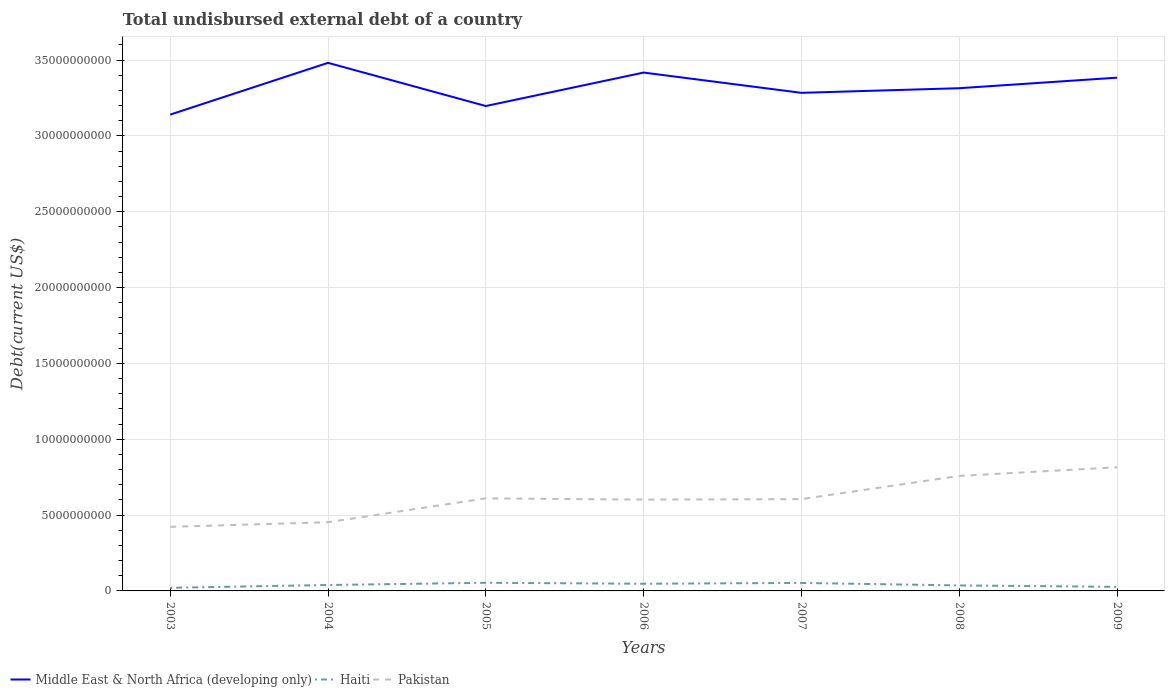Does the line corresponding to Middle East & North Africa (developing only) intersect with the line corresponding to Haiti?
Give a very brief answer. No. Across all years, what is the maximum total undisbursed external debt in Pakistan?
Offer a terse response. 4.22e+09. What is the total total undisbursed external debt in Haiti in the graph?
Provide a short and direct response. -2.67e+08. What is the difference between the highest and the second highest total undisbursed external debt in Pakistan?
Your answer should be compact. 3.93e+09. What is the difference between the highest and the lowest total undisbursed external debt in Middle East & North Africa (developing only)?
Your response must be concise. 3. Is the total undisbursed external debt in Middle East & North Africa (developing only) strictly greater than the total undisbursed external debt in Haiti over the years?
Keep it short and to the point. No. How many lines are there?
Offer a very short reply. 3. How many years are there in the graph?
Offer a terse response. 7. Does the graph contain any zero values?
Give a very brief answer. No. Does the graph contain grids?
Provide a short and direct response. Yes. How are the legend labels stacked?
Your response must be concise. Horizontal. What is the title of the graph?
Your response must be concise. Total undisbursed external debt of a country. Does "Switzerland" appear as one of the legend labels in the graph?
Give a very brief answer. No. What is the label or title of the X-axis?
Make the answer very short. Years. What is the label or title of the Y-axis?
Your answer should be very brief. Debt(current US$). What is the Debt(current US$) in Middle East & North Africa (developing only) in 2003?
Your answer should be very brief. 3.14e+1. What is the Debt(current US$) of Haiti in 2003?
Provide a short and direct response. 2.06e+08. What is the Debt(current US$) of Pakistan in 2003?
Your response must be concise. 4.22e+09. What is the Debt(current US$) of Middle East & North Africa (developing only) in 2004?
Keep it short and to the point. 3.48e+1. What is the Debt(current US$) in Haiti in 2004?
Ensure brevity in your answer.  3.90e+08. What is the Debt(current US$) of Pakistan in 2004?
Offer a terse response. 4.53e+09. What is the Debt(current US$) in Middle East & North Africa (developing only) in 2005?
Offer a terse response. 3.20e+1. What is the Debt(current US$) of Haiti in 2005?
Offer a very short reply. 5.37e+08. What is the Debt(current US$) of Pakistan in 2005?
Your answer should be very brief. 6.10e+09. What is the Debt(current US$) of Middle East & North Africa (developing only) in 2006?
Make the answer very short. 3.42e+1. What is the Debt(current US$) of Haiti in 2006?
Keep it short and to the point. 4.73e+08. What is the Debt(current US$) in Pakistan in 2006?
Your response must be concise. 6.02e+09. What is the Debt(current US$) of Middle East & North Africa (developing only) in 2007?
Provide a succinct answer. 3.28e+1. What is the Debt(current US$) in Haiti in 2007?
Give a very brief answer. 5.27e+08. What is the Debt(current US$) of Pakistan in 2007?
Your response must be concise. 6.05e+09. What is the Debt(current US$) of Middle East & North Africa (developing only) in 2008?
Keep it short and to the point. 3.31e+1. What is the Debt(current US$) of Haiti in 2008?
Offer a terse response. 3.63e+08. What is the Debt(current US$) of Pakistan in 2008?
Offer a terse response. 7.58e+09. What is the Debt(current US$) of Middle East & North Africa (developing only) in 2009?
Your answer should be very brief. 3.38e+1. What is the Debt(current US$) in Haiti in 2009?
Your answer should be very brief. 2.68e+08. What is the Debt(current US$) of Pakistan in 2009?
Ensure brevity in your answer.  8.15e+09. Across all years, what is the maximum Debt(current US$) in Middle East & North Africa (developing only)?
Offer a terse response. 3.48e+1. Across all years, what is the maximum Debt(current US$) in Haiti?
Your answer should be compact. 5.37e+08. Across all years, what is the maximum Debt(current US$) of Pakistan?
Offer a very short reply. 8.15e+09. Across all years, what is the minimum Debt(current US$) of Middle East & North Africa (developing only)?
Give a very brief answer. 3.14e+1. Across all years, what is the minimum Debt(current US$) in Haiti?
Offer a terse response. 2.06e+08. Across all years, what is the minimum Debt(current US$) in Pakistan?
Ensure brevity in your answer.  4.22e+09. What is the total Debt(current US$) in Middle East & North Africa (developing only) in the graph?
Make the answer very short. 2.32e+11. What is the total Debt(current US$) in Haiti in the graph?
Ensure brevity in your answer.  2.76e+09. What is the total Debt(current US$) of Pakistan in the graph?
Keep it short and to the point. 4.27e+1. What is the difference between the Debt(current US$) in Middle East & North Africa (developing only) in 2003 and that in 2004?
Make the answer very short. -3.41e+09. What is the difference between the Debt(current US$) in Haiti in 2003 and that in 2004?
Make the answer very short. -1.83e+08. What is the difference between the Debt(current US$) of Pakistan in 2003 and that in 2004?
Provide a succinct answer. -3.04e+08. What is the difference between the Debt(current US$) of Middle East & North Africa (developing only) in 2003 and that in 2005?
Make the answer very short. -5.65e+08. What is the difference between the Debt(current US$) in Haiti in 2003 and that in 2005?
Your answer should be compact. -3.31e+08. What is the difference between the Debt(current US$) of Pakistan in 2003 and that in 2005?
Provide a short and direct response. -1.88e+09. What is the difference between the Debt(current US$) in Middle East & North Africa (developing only) in 2003 and that in 2006?
Offer a very short reply. -2.77e+09. What is the difference between the Debt(current US$) of Haiti in 2003 and that in 2006?
Provide a short and direct response. -2.67e+08. What is the difference between the Debt(current US$) in Pakistan in 2003 and that in 2006?
Your answer should be very brief. -1.80e+09. What is the difference between the Debt(current US$) in Middle East & North Africa (developing only) in 2003 and that in 2007?
Ensure brevity in your answer.  -1.44e+09. What is the difference between the Debt(current US$) of Haiti in 2003 and that in 2007?
Make the answer very short. -3.20e+08. What is the difference between the Debt(current US$) of Pakistan in 2003 and that in 2007?
Keep it short and to the point. -1.83e+09. What is the difference between the Debt(current US$) of Middle East & North Africa (developing only) in 2003 and that in 2008?
Offer a very short reply. -1.74e+09. What is the difference between the Debt(current US$) of Haiti in 2003 and that in 2008?
Offer a very short reply. -1.56e+08. What is the difference between the Debt(current US$) in Pakistan in 2003 and that in 2008?
Make the answer very short. -3.36e+09. What is the difference between the Debt(current US$) in Middle East & North Africa (developing only) in 2003 and that in 2009?
Your response must be concise. -2.44e+09. What is the difference between the Debt(current US$) of Haiti in 2003 and that in 2009?
Your response must be concise. -6.14e+07. What is the difference between the Debt(current US$) of Pakistan in 2003 and that in 2009?
Ensure brevity in your answer.  -3.93e+09. What is the difference between the Debt(current US$) of Middle East & North Africa (developing only) in 2004 and that in 2005?
Ensure brevity in your answer.  2.85e+09. What is the difference between the Debt(current US$) of Haiti in 2004 and that in 2005?
Your answer should be compact. -1.47e+08. What is the difference between the Debt(current US$) of Pakistan in 2004 and that in 2005?
Give a very brief answer. -1.58e+09. What is the difference between the Debt(current US$) of Middle East & North Africa (developing only) in 2004 and that in 2006?
Ensure brevity in your answer.  6.42e+08. What is the difference between the Debt(current US$) of Haiti in 2004 and that in 2006?
Offer a very short reply. -8.38e+07. What is the difference between the Debt(current US$) of Pakistan in 2004 and that in 2006?
Make the answer very short. -1.49e+09. What is the difference between the Debt(current US$) in Middle East & North Africa (developing only) in 2004 and that in 2007?
Make the answer very short. 1.98e+09. What is the difference between the Debt(current US$) of Haiti in 2004 and that in 2007?
Offer a terse response. -1.37e+08. What is the difference between the Debt(current US$) in Pakistan in 2004 and that in 2007?
Keep it short and to the point. -1.52e+09. What is the difference between the Debt(current US$) of Middle East & North Africa (developing only) in 2004 and that in 2008?
Offer a terse response. 1.67e+09. What is the difference between the Debt(current US$) in Haiti in 2004 and that in 2008?
Your answer should be very brief. 2.68e+07. What is the difference between the Debt(current US$) in Pakistan in 2004 and that in 2008?
Provide a succinct answer. -3.06e+09. What is the difference between the Debt(current US$) in Middle East & North Africa (developing only) in 2004 and that in 2009?
Offer a very short reply. 9.78e+08. What is the difference between the Debt(current US$) in Haiti in 2004 and that in 2009?
Keep it short and to the point. 1.22e+08. What is the difference between the Debt(current US$) of Pakistan in 2004 and that in 2009?
Offer a very short reply. -3.63e+09. What is the difference between the Debt(current US$) in Middle East & North Africa (developing only) in 2005 and that in 2006?
Offer a very short reply. -2.21e+09. What is the difference between the Debt(current US$) of Haiti in 2005 and that in 2006?
Provide a succinct answer. 6.37e+07. What is the difference between the Debt(current US$) of Pakistan in 2005 and that in 2006?
Offer a very short reply. 8.43e+07. What is the difference between the Debt(current US$) of Middle East & North Africa (developing only) in 2005 and that in 2007?
Provide a succinct answer. -8.70e+08. What is the difference between the Debt(current US$) in Haiti in 2005 and that in 2007?
Offer a terse response. 1.06e+07. What is the difference between the Debt(current US$) of Pakistan in 2005 and that in 2007?
Provide a short and direct response. 5.10e+07. What is the difference between the Debt(current US$) of Middle East & North Africa (developing only) in 2005 and that in 2008?
Ensure brevity in your answer.  -1.18e+09. What is the difference between the Debt(current US$) in Haiti in 2005 and that in 2008?
Ensure brevity in your answer.  1.74e+08. What is the difference between the Debt(current US$) in Pakistan in 2005 and that in 2008?
Provide a succinct answer. -1.48e+09. What is the difference between the Debt(current US$) in Middle East & North Africa (developing only) in 2005 and that in 2009?
Offer a terse response. -1.87e+09. What is the difference between the Debt(current US$) in Haiti in 2005 and that in 2009?
Provide a short and direct response. 2.69e+08. What is the difference between the Debt(current US$) of Pakistan in 2005 and that in 2009?
Make the answer very short. -2.05e+09. What is the difference between the Debt(current US$) in Middle East & North Africa (developing only) in 2006 and that in 2007?
Give a very brief answer. 1.34e+09. What is the difference between the Debt(current US$) in Haiti in 2006 and that in 2007?
Your answer should be compact. -5.31e+07. What is the difference between the Debt(current US$) in Pakistan in 2006 and that in 2007?
Provide a short and direct response. -3.33e+07. What is the difference between the Debt(current US$) of Middle East & North Africa (developing only) in 2006 and that in 2008?
Provide a succinct answer. 1.03e+09. What is the difference between the Debt(current US$) in Haiti in 2006 and that in 2008?
Your answer should be very brief. 1.11e+08. What is the difference between the Debt(current US$) in Pakistan in 2006 and that in 2008?
Your answer should be compact. -1.56e+09. What is the difference between the Debt(current US$) in Middle East & North Africa (developing only) in 2006 and that in 2009?
Make the answer very short. 3.36e+08. What is the difference between the Debt(current US$) in Haiti in 2006 and that in 2009?
Make the answer very short. 2.06e+08. What is the difference between the Debt(current US$) of Pakistan in 2006 and that in 2009?
Ensure brevity in your answer.  -2.13e+09. What is the difference between the Debt(current US$) in Middle East & North Africa (developing only) in 2007 and that in 2008?
Your answer should be very brief. -3.05e+08. What is the difference between the Debt(current US$) in Haiti in 2007 and that in 2008?
Your answer should be compact. 1.64e+08. What is the difference between the Debt(current US$) of Pakistan in 2007 and that in 2008?
Your answer should be compact. -1.53e+09. What is the difference between the Debt(current US$) of Middle East & North Africa (developing only) in 2007 and that in 2009?
Provide a short and direct response. -1.00e+09. What is the difference between the Debt(current US$) in Haiti in 2007 and that in 2009?
Your answer should be compact. 2.59e+08. What is the difference between the Debt(current US$) in Pakistan in 2007 and that in 2009?
Your response must be concise. -2.10e+09. What is the difference between the Debt(current US$) of Middle East & North Africa (developing only) in 2008 and that in 2009?
Provide a succinct answer. -6.95e+08. What is the difference between the Debt(current US$) of Haiti in 2008 and that in 2009?
Provide a short and direct response. 9.49e+07. What is the difference between the Debt(current US$) in Pakistan in 2008 and that in 2009?
Offer a very short reply. -5.69e+08. What is the difference between the Debt(current US$) of Middle East & North Africa (developing only) in 2003 and the Debt(current US$) of Haiti in 2004?
Provide a short and direct response. 3.10e+1. What is the difference between the Debt(current US$) of Middle East & North Africa (developing only) in 2003 and the Debt(current US$) of Pakistan in 2004?
Keep it short and to the point. 2.69e+1. What is the difference between the Debt(current US$) of Haiti in 2003 and the Debt(current US$) of Pakistan in 2004?
Provide a succinct answer. -4.32e+09. What is the difference between the Debt(current US$) of Middle East & North Africa (developing only) in 2003 and the Debt(current US$) of Haiti in 2005?
Ensure brevity in your answer.  3.09e+1. What is the difference between the Debt(current US$) of Middle East & North Africa (developing only) in 2003 and the Debt(current US$) of Pakistan in 2005?
Your answer should be very brief. 2.53e+1. What is the difference between the Debt(current US$) of Haiti in 2003 and the Debt(current US$) of Pakistan in 2005?
Your response must be concise. -5.90e+09. What is the difference between the Debt(current US$) of Middle East & North Africa (developing only) in 2003 and the Debt(current US$) of Haiti in 2006?
Your response must be concise. 3.09e+1. What is the difference between the Debt(current US$) of Middle East & North Africa (developing only) in 2003 and the Debt(current US$) of Pakistan in 2006?
Your answer should be very brief. 2.54e+1. What is the difference between the Debt(current US$) in Haiti in 2003 and the Debt(current US$) in Pakistan in 2006?
Make the answer very short. -5.81e+09. What is the difference between the Debt(current US$) in Middle East & North Africa (developing only) in 2003 and the Debt(current US$) in Haiti in 2007?
Your answer should be compact. 3.09e+1. What is the difference between the Debt(current US$) of Middle East & North Africa (developing only) in 2003 and the Debt(current US$) of Pakistan in 2007?
Offer a terse response. 2.54e+1. What is the difference between the Debt(current US$) in Haiti in 2003 and the Debt(current US$) in Pakistan in 2007?
Your answer should be compact. -5.85e+09. What is the difference between the Debt(current US$) in Middle East & North Africa (developing only) in 2003 and the Debt(current US$) in Haiti in 2008?
Keep it short and to the point. 3.10e+1. What is the difference between the Debt(current US$) of Middle East & North Africa (developing only) in 2003 and the Debt(current US$) of Pakistan in 2008?
Offer a very short reply. 2.38e+1. What is the difference between the Debt(current US$) in Haiti in 2003 and the Debt(current US$) in Pakistan in 2008?
Your response must be concise. -7.38e+09. What is the difference between the Debt(current US$) in Middle East & North Africa (developing only) in 2003 and the Debt(current US$) in Haiti in 2009?
Offer a terse response. 3.11e+1. What is the difference between the Debt(current US$) of Middle East & North Africa (developing only) in 2003 and the Debt(current US$) of Pakistan in 2009?
Keep it short and to the point. 2.33e+1. What is the difference between the Debt(current US$) of Haiti in 2003 and the Debt(current US$) of Pakistan in 2009?
Provide a succinct answer. -7.95e+09. What is the difference between the Debt(current US$) in Middle East & North Africa (developing only) in 2004 and the Debt(current US$) in Haiti in 2005?
Your response must be concise. 3.43e+1. What is the difference between the Debt(current US$) of Middle East & North Africa (developing only) in 2004 and the Debt(current US$) of Pakistan in 2005?
Make the answer very short. 2.87e+1. What is the difference between the Debt(current US$) of Haiti in 2004 and the Debt(current US$) of Pakistan in 2005?
Offer a terse response. -5.71e+09. What is the difference between the Debt(current US$) of Middle East & North Africa (developing only) in 2004 and the Debt(current US$) of Haiti in 2006?
Offer a very short reply. 3.43e+1. What is the difference between the Debt(current US$) of Middle East & North Africa (developing only) in 2004 and the Debt(current US$) of Pakistan in 2006?
Offer a very short reply. 2.88e+1. What is the difference between the Debt(current US$) in Haiti in 2004 and the Debt(current US$) in Pakistan in 2006?
Offer a terse response. -5.63e+09. What is the difference between the Debt(current US$) of Middle East & North Africa (developing only) in 2004 and the Debt(current US$) of Haiti in 2007?
Keep it short and to the point. 3.43e+1. What is the difference between the Debt(current US$) of Middle East & North Africa (developing only) in 2004 and the Debt(current US$) of Pakistan in 2007?
Make the answer very short. 2.88e+1. What is the difference between the Debt(current US$) of Haiti in 2004 and the Debt(current US$) of Pakistan in 2007?
Ensure brevity in your answer.  -5.66e+09. What is the difference between the Debt(current US$) in Middle East & North Africa (developing only) in 2004 and the Debt(current US$) in Haiti in 2008?
Offer a very short reply. 3.45e+1. What is the difference between the Debt(current US$) of Middle East & North Africa (developing only) in 2004 and the Debt(current US$) of Pakistan in 2008?
Your answer should be compact. 2.72e+1. What is the difference between the Debt(current US$) in Haiti in 2004 and the Debt(current US$) in Pakistan in 2008?
Ensure brevity in your answer.  -7.20e+09. What is the difference between the Debt(current US$) of Middle East & North Africa (developing only) in 2004 and the Debt(current US$) of Haiti in 2009?
Your response must be concise. 3.46e+1. What is the difference between the Debt(current US$) of Middle East & North Africa (developing only) in 2004 and the Debt(current US$) of Pakistan in 2009?
Your answer should be compact. 2.67e+1. What is the difference between the Debt(current US$) in Haiti in 2004 and the Debt(current US$) in Pakistan in 2009?
Your answer should be compact. -7.76e+09. What is the difference between the Debt(current US$) in Middle East & North Africa (developing only) in 2005 and the Debt(current US$) in Haiti in 2006?
Keep it short and to the point. 3.15e+1. What is the difference between the Debt(current US$) of Middle East & North Africa (developing only) in 2005 and the Debt(current US$) of Pakistan in 2006?
Offer a very short reply. 2.60e+1. What is the difference between the Debt(current US$) in Haiti in 2005 and the Debt(current US$) in Pakistan in 2006?
Your answer should be very brief. -5.48e+09. What is the difference between the Debt(current US$) of Middle East & North Africa (developing only) in 2005 and the Debt(current US$) of Haiti in 2007?
Ensure brevity in your answer.  3.14e+1. What is the difference between the Debt(current US$) of Middle East & North Africa (developing only) in 2005 and the Debt(current US$) of Pakistan in 2007?
Ensure brevity in your answer.  2.59e+1. What is the difference between the Debt(current US$) in Haiti in 2005 and the Debt(current US$) in Pakistan in 2007?
Your response must be concise. -5.52e+09. What is the difference between the Debt(current US$) in Middle East & North Africa (developing only) in 2005 and the Debt(current US$) in Haiti in 2008?
Provide a short and direct response. 3.16e+1. What is the difference between the Debt(current US$) of Middle East & North Africa (developing only) in 2005 and the Debt(current US$) of Pakistan in 2008?
Your answer should be compact. 2.44e+1. What is the difference between the Debt(current US$) of Haiti in 2005 and the Debt(current US$) of Pakistan in 2008?
Your answer should be very brief. -7.05e+09. What is the difference between the Debt(current US$) of Middle East & North Africa (developing only) in 2005 and the Debt(current US$) of Haiti in 2009?
Ensure brevity in your answer.  3.17e+1. What is the difference between the Debt(current US$) of Middle East & North Africa (developing only) in 2005 and the Debt(current US$) of Pakistan in 2009?
Keep it short and to the point. 2.38e+1. What is the difference between the Debt(current US$) in Haiti in 2005 and the Debt(current US$) in Pakistan in 2009?
Make the answer very short. -7.62e+09. What is the difference between the Debt(current US$) of Middle East & North Africa (developing only) in 2006 and the Debt(current US$) of Haiti in 2007?
Your response must be concise. 3.37e+1. What is the difference between the Debt(current US$) in Middle East & North Africa (developing only) in 2006 and the Debt(current US$) in Pakistan in 2007?
Ensure brevity in your answer.  2.81e+1. What is the difference between the Debt(current US$) of Haiti in 2006 and the Debt(current US$) of Pakistan in 2007?
Provide a short and direct response. -5.58e+09. What is the difference between the Debt(current US$) of Middle East & North Africa (developing only) in 2006 and the Debt(current US$) of Haiti in 2008?
Your response must be concise. 3.38e+1. What is the difference between the Debt(current US$) of Middle East & North Africa (developing only) in 2006 and the Debt(current US$) of Pakistan in 2008?
Offer a very short reply. 2.66e+1. What is the difference between the Debt(current US$) in Haiti in 2006 and the Debt(current US$) in Pakistan in 2008?
Your answer should be compact. -7.11e+09. What is the difference between the Debt(current US$) of Middle East & North Africa (developing only) in 2006 and the Debt(current US$) of Haiti in 2009?
Offer a terse response. 3.39e+1. What is the difference between the Debt(current US$) of Middle East & North Africa (developing only) in 2006 and the Debt(current US$) of Pakistan in 2009?
Offer a very short reply. 2.60e+1. What is the difference between the Debt(current US$) of Haiti in 2006 and the Debt(current US$) of Pakistan in 2009?
Offer a very short reply. -7.68e+09. What is the difference between the Debt(current US$) in Middle East & North Africa (developing only) in 2007 and the Debt(current US$) in Haiti in 2008?
Offer a terse response. 3.25e+1. What is the difference between the Debt(current US$) in Middle East & North Africa (developing only) in 2007 and the Debt(current US$) in Pakistan in 2008?
Offer a terse response. 2.53e+1. What is the difference between the Debt(current US$) in Haiti in 2007 and the Debt(current US$) in Pakistan in 2008?
Give a very brief answer. -7.06e+09. What is the difference between the Debt(current US$) of Middle East & North Africa (developing only) in 2007 and the Debt(current US$) of Haiti in 2009?
Provide a short and direct response. 3.26e+1. What is the difference between the Debt(current US$) of Middle East & North Africa (developing only) in 2007 and the Debt(current US$) of Pakistan in 2009?
Your response must be concise. 2.47e+1. What is the difference between the Debt(current US$) in Haiti in 2007 and the Debt(current US$) in Pakistan in 2009?
Offer a terse response. -7.63e+09. What is the difference between the Debt(current US$) of Middle East & North Africa (developing only) in 2008 and the Debt(current US$) of Haiti in 2009?
Give a very brief answer. 3.29e+1. What is the difference between the Debt(current US$) of Middle East & North Africa (developing only) in 2008 and the Debt(current US$) of Pakistan in 2009?
Ensure brevity in your answer.  2.50e+1. What is the difference between the Debt(current US$) in Haiti in 2008 and the Debt(current US$) in Pakistan in 2009?
Your answer should be very brief. -7.79e+09. What is the average Debt(current US$) of Middle East & North Africa (developing only) per year?
Provide a short and direct response. 3.32e+1. What is the average Debt(current US$) in Haiti per year?
Offer a terse response. 3.95e+08. What is the average Debt(current US$) in Pakistan per year?
Provide a short and direct response. 6.10e+09. In the year 2003, what is the difference between the Debt(current US$) of Middle East & North Africa (developing only) and Debt(current US$) of Haiti?
Offer a very short reply. 3.12e+1. In the year 2003, what is the difference between the Debt(current US$) in Middle East & North Africa (developing only) and Debt(current US$) in Pakistan?
Keep it short and to the point. 2.72e+1. In the year 2003, what is the difference between the Debt(current US$) in Haiti and Debt(current US$) in Pakistan?
Provide a short and direct response. -4.02e+09. In the year 2004, what is the difference between the Debt(current US$) in Middle East & North Africa (developing only) and Debt(current US$) in Haiti?
Provide a short and direct response. 3.44e+1. In the year 2004, what is the difference between the Debt(current US$) in Middle East & North Africa (developing only) and Debt(current US$) in Pakistan?
Keep it short and to the point. 3.03e+1. In the year 2004, what is the difference between the Debt(current US$) in Haiti and Debt(current US$) in Pakistan?
Offer a very short reply. -4.14e+09. In the year 2005, what is the difference between the Debt(current US$) in Middle East & North Africa (developing only) and Debt(current US$) in Haiti?
Offer a very short reply. 3.14e+1. In the year 2005, what is the difference between the Debt(current US$) of Middle East & North Africa (developing only) and Debt(current US$) of Pakistan?
Make the answer very short. 2.59e+1. In the year 2005, what is the difference between the Debt(current US$) in Haiti and Debt(current US$) in Pakistan?
Your answer should be very brief. -5.57e+09. In the year 2006, what is the difference between the Debt(current US$) of Middle East & North Africa (developing only) and Debt(current US$) of Haiti?
Offer a terse response. 3.37e+1. In the year 2006, what is the difference between the Debt(current US$) of Middle East & North Africa (developing only) and Debt(current US$) of Pakistan?
Offer a very short reply. 2.82e+1. In the year 2006, what is the difference between the Debt(current US$) in Haiti and Debt(current US$) in Pakistan?
Offer a terse response. -5.55e+09. In the year 2007, what is the difference between the Debt(current US$) in Middle East & North Africa (developing only) and Debt(current US$) in Haiti?
Provide a short and direct response. 3.23e+1. In the year 2007, what is the difference between the Debt(current US$) of Middle East & North Africa (developing only) and Debt(current US$) of Pakistan?
Ensure brevity in your answer.  2.68e+1. In the year 2007, what is the difference between the Debt(current US$) in Haiti and Debt(current US$) in Pakistan?
Provide a succinct answer. -5.53e+09. In the year 2008, what is the difference between the Debt(current US$) in Middle East & North Africa (developing only) and Debt(current US$) in Haiti?
Give a very brief answer. 3.28e+1. In the year 2008, what is the difference between the Debt(current US$) in Middle East & North Africa (developing only) and Debt(current US$) in Pakistan?
Provide a succinct answer. 2.56e+1. In the year 2008, what is the difference between the Debt(current US$) of Haiti and Debt(current US$) of Pakistan?
Offer a terse response. -7.22e+09. In the year 2009, what is the difference between the Debt(current US$) of Middle East & North Africa (developing only) and Debt(current US$) of Haiti?
Your response must be concise. 3.36e+1. In the year 2009, what is the difference between the Debt(current US$) of Middle East & North Africa (developing only) and Debt(current US$) of Pakistan?
Give a very brief answer. 2.57e+1. In the year 2009, what is the difference between the Debt(current US$) of Haiti and Debt(current US$) of Pakistan?
Your answer should be very brief. -7.89e+09. What is the ratio of the Debt(current US$) of Middle East & North Africa (developing only) in 2003 to that in 2004?
Your response must be concise. 0.9. What is the ratio of the Debt(current US$) of Haiti in 2003 to that in 2004?
Your response must be concise. 0.53. What is the ratio of the Debt(current US$) in Pakistan in 2003 to that in 2004?
Your answer should be compact. 0.93. What is the ratio of the Debt(current US$) of Middle East & North Africa (developing only) in 2003 to that in 2005?
Offer a terse response. 0.98. What is the ratio of the Debt(current US$) of Haiti in 2003 to that in 2005?
Make the answer very short. 0.38. What is the ratio of the Debt(current US$) of Pakistan in 2003 to that in 2005?
Offer a terse response. 0.69. What is the ratio of the Debt(current US$) in Middle East & North Africa (developing only) in 2003 to that in 2006?
Make the answer very short. 0.92. What is the ratio of the Debt(current US$) of Haiti in 2003 to that in 2006?
Offer a very short reply. 0.44. What is the ratio of the Debt(current US$) in Pakistan in 2003 to that in 2006?
Make the answer very short. 0.7. What is the ratio of the Debt(current US$) in Middle East & North Africa (developing only) in 2003 to that in 2007?
Your answer should be compact. 0.96. What is the ratio of the Debt(current US$) of Haiti in 2003 to that in 2007?
Offer a terse response. 0.39. What is the ratio of the Debt(current US$) in Pakistan in 2003 to that in 2007?
Give a very brief answer. 0.7. What is the ratio of the Debt(current US$) in Middle East & North Africa (developing only) in 2003 to that in 2008?
Provide a succinct answer. 0.95. What is the ratio of the Debt(current US$) of Haiti in 2003 to that in 2008?
Offer a very short reply. 0.57. What is the ratio of the Debt(current US$) in Pakistan in 2003 to that in 2008?
Keep it short and to the point. 0.56. What is the ratio of the Debt(current US$) of Middle East & North Africa (developing only) in 2003 to that in 2009?
Ensure brevity in your answer.  0.93. What is the ratio of the Debt(current US$) of Haiti in 2003 to that in 2009?
Provide a succinct answer. 0.77. What is the ratio of the Debt(current US$) of Pakistan in 2003 to that in 2009?
Your response must be concise. 0.52. What is the ratio of the Debt(current US$) in Middle East & North Africa (developing only) in 2004 to that in 2005?
Your response must be concise. 1.09. What is the ratio of the Debt(current US$) of Haiti in 2004 to that in 2005?
Keep it short and to the point. 0.73. What is the ratio of the Debt(current US$) in Pakistan in 2004 to that in 2005?
Your answer should be compact. 0.74. What is the ratio of the Debt(current US$) in Middle East & North Africa (developing only) in 2004 to that in 2006?
Your answer should be compact. 1.02. What is the ratio of the Debt(current US$) of Haiti in 2004 to that in 2006?
Ensure brevity in your answer.  0.82. What is the ratio of the Debt(current US$) in Pakistan in 2004 to that in 2006?
Ensure brevity in your answer.  0.75. What is the ratio of the Debt(current US$) of Middle East & North Africa (developing only) in 2004 to that in 2007?
Your response must be concise. 1.06. What is the ratio of the Debt(current US$) in Haiti in 2004 to that in 2007?
Keep it short and to the point. 0.74. What is the ratio of the Debt(current US$) in Pakistan in 2004 to that in 2007?
Your answer should be very brief. 0.75. What is the ratio of the Debt(current US$) in Middle East & North Africa (developing only) in 2004 to that in 2008?
Keep it short and to the point. 1.05. What is the ratio of the Debt(current US$) of Haiti in 2004 to that in 2008?
Offer a very short reply. 1.07. What is the ratio of the Debt(current US$) in Pakistan in 2004 to that in 2008?
Ensure brevity in your answer.  0.6. What is the ratio of the Debt(current US$) in Middle East & North Africa (developing only) in 2004 to that in 2009?
Your answer should be compact. 1.03. What is the ratio of the Debt(current US$) of Haiti in 2004 to that in 2009?
Your answer should be very brief. 1.45. What is the ratio of the Debt(current US$) in Pakistan in 2004 to that in 2009?
Provide a short and direct response. 0.56. What is the ratio of the Debt(current US$) of Middle East & North Africa (developing only) in 2005 to that in 2006?
Provide a short and direct response. 0.94. What is the ratio of the Debt(current US$) of Haiti in 2005 to that in 2006?
Offer a terse response. 1.13. What is the ratio of the Debt(current US$) of Middle East & North Africa (developing only) in 2005 to that in 2007?
Offer a very short reply. 0.97. What is the ratio of the Debt(current US$) of Haiti in 2005 to that in 2007?
Your answer should be very brief. 1.02. What is the ratio of the Debt(current US$) in Pakistan in 2005 to that in 2007?
Make the answer very short. 1.01. What is the ratio of the Debt(current US$) of Middle East & North Africa (developing only) in 2005 to that in 2008?
Provide a short and direct response. 0.96. What is the ratio of the Debt(current US$) of Haiti in 2005 to that in 2008?
Give a very brief answer. 1.48. What is the ratio of the Debt(current US$) of Pakistan in 2005 to that in 2008?
Provide a short and direct response. 0.8. What is the ratio of the Debt(current US$) of Middle East & North Africa (developing only) in 2005 to that in 2009?
Keep it short and to the point. 0.94. What is the ratio of the Debt(current US$) of Haiti in 2005 to that in 2009?
Offer a terse response. 2. What is the ratio of the Debt(current US$) in Pakistan in 2005 to that in 2009?
Your answer should be very brief. 0.75. What is the ratio of the Debt(current US$) of Middle East & North Africa (developing only) in 2006 to that in 2007?
Keep it short and to the point. 1.04. What is the ratio of the Debt(current US$) in Haiti in 2006 to that in 2007?
Ensure brevity in your answer.  0.9. What is the ratio of the Debt(current US$) of Pakistan in 2006 to that in 2007?
Give a very brief answer. 0.99. What is the ratio of the Debt(current US$) of Middle East & North Africa (developing only) in 2006 to that in 2008?
Offer a very short reply. 1.03. What is the ratio of the Debt(current US$) of Haiti in 2006 to that in 2008?
Give a very brief answer. 1.3. What is the ratio of the Debt(current US$) of Pakistan in 2006 to that in 2008?
Keep it short and to the point. 0.79. What is the ratio of the Debt(current US$) of Middle East & North Africa (developing only) in 2006 to that in 2009?
Offer a very short reply. 1.01. What is the ratio of the Debt(current US$) in Haiti in 2006 to that in 2009?
Provide a succinct answer. 1.77. What is the ratio of the Debt(current US$) of Pakistan in 2006 to that in 2009?
Your answer should be compact. 0.74. What is the ratio of the Debt(current US$) in Middle East & North Africa (developing only) in 2007 to that in 2008?
Your response must be concise. 0.99. What is the ratio of the Debt(current US$) of Haiti in 2007 to that in 2008?
Provide a short and direct response. 1.45. What is the ratio of the Debt(current US$) of Pakistan in 2007 to that in 2008?
Your answer should be compact. 0.8. What is the ratio of the Debt(current US$) in Middle East & North Africa (developing only) in 2007 to that in 2009?
Your answer should be compact. 0.97. What is the ratio of the Debt(current US$) in Haiti in 2007 to that in 2009?
Ensure brevity in your answer.  1.97. What is the ratio of the Debt(current US$) of Pakistan in 2007 to that in 2009?
Give a very brief answer. 0.74. What is the ratio of the Debt(current US$) of Middle East & North Africa (developing only) in 2008 to that in 2009?
Give a very brief answer. 0.98. What is the ratio of the Debt(current US$) in Haiti in 2008 to that in 2009?
Your answer should be very brief. 1.35. What is the ratio of the Debt(current US$) in Pakistan in 2008 to that in 2009?
Your answer should be very brief. 0.93. What is the difference between the highest and the second highest Debt(current US$) of Middle East & North Africa (developing only)?
Your answer should be very brief. 6.42e+08. What is the difference between the highest and the second highest Debt(current US$) of Haiti?
Provide a short and direct response. 1.06e+07. What is the difference between the highest and the second highest Debt(current US$) of Pakistan?
Keep it short and to the point. 5.69e+08. What is the difference between the highest and the lowest Debt(current US$) of Middle East & North Africa (developing only)?
Provide a short and direct response. 3.41e+09. What is the difference between the highest and the lowest Debt(current US$) in Haiti?
Provide a short and direct response. 3.31e+08. What is the difference between the highest and the lowest Debt(current US$) of Pakistan?
Provide a succinct answer. 3.93e+09. 